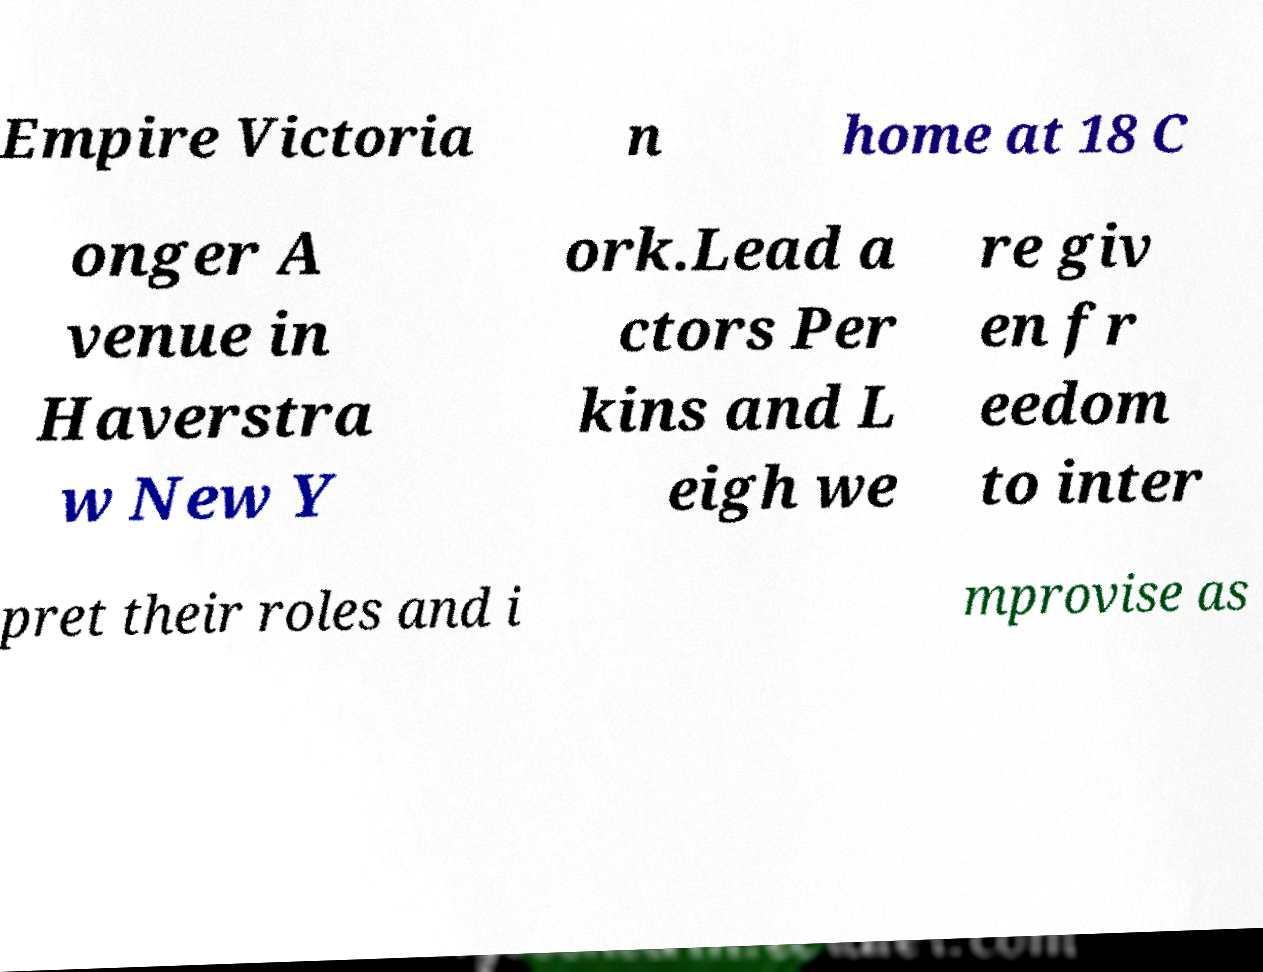Could you extract and type out the text from this image? Empire Victoria n home at 18 C onger A venue in Haverstra w New Y ork.Lead a ctors Per kins and L eigh we re giv en fr eedom to inter pret their roles and i mprovise as 